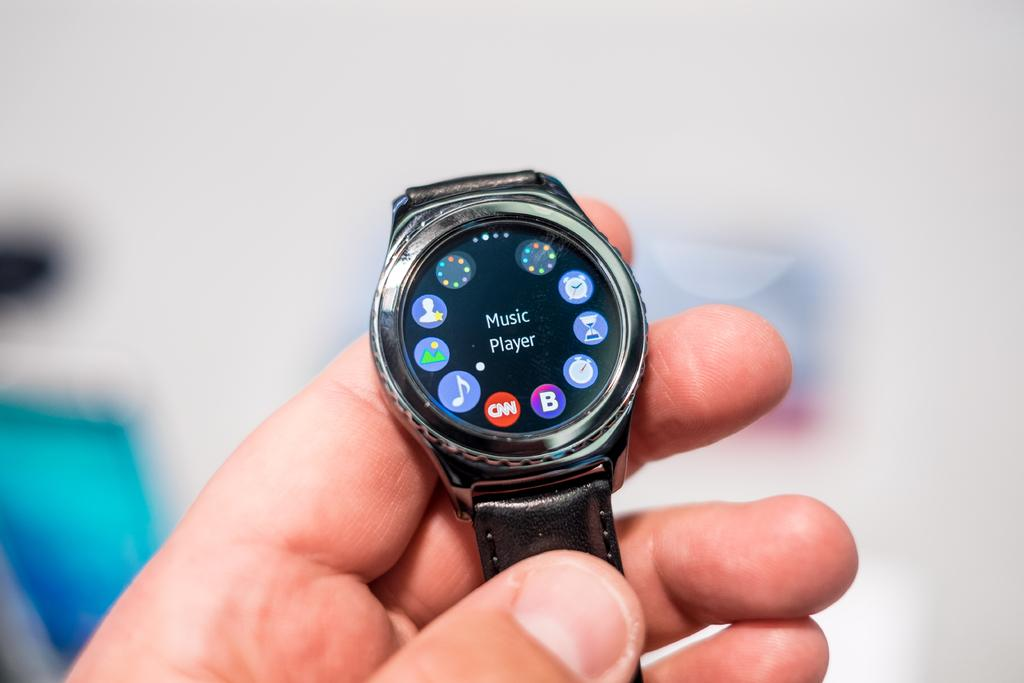<image>
Relay a brief, clear account of the picture shown. A black watch says "Music Player" on the face. 